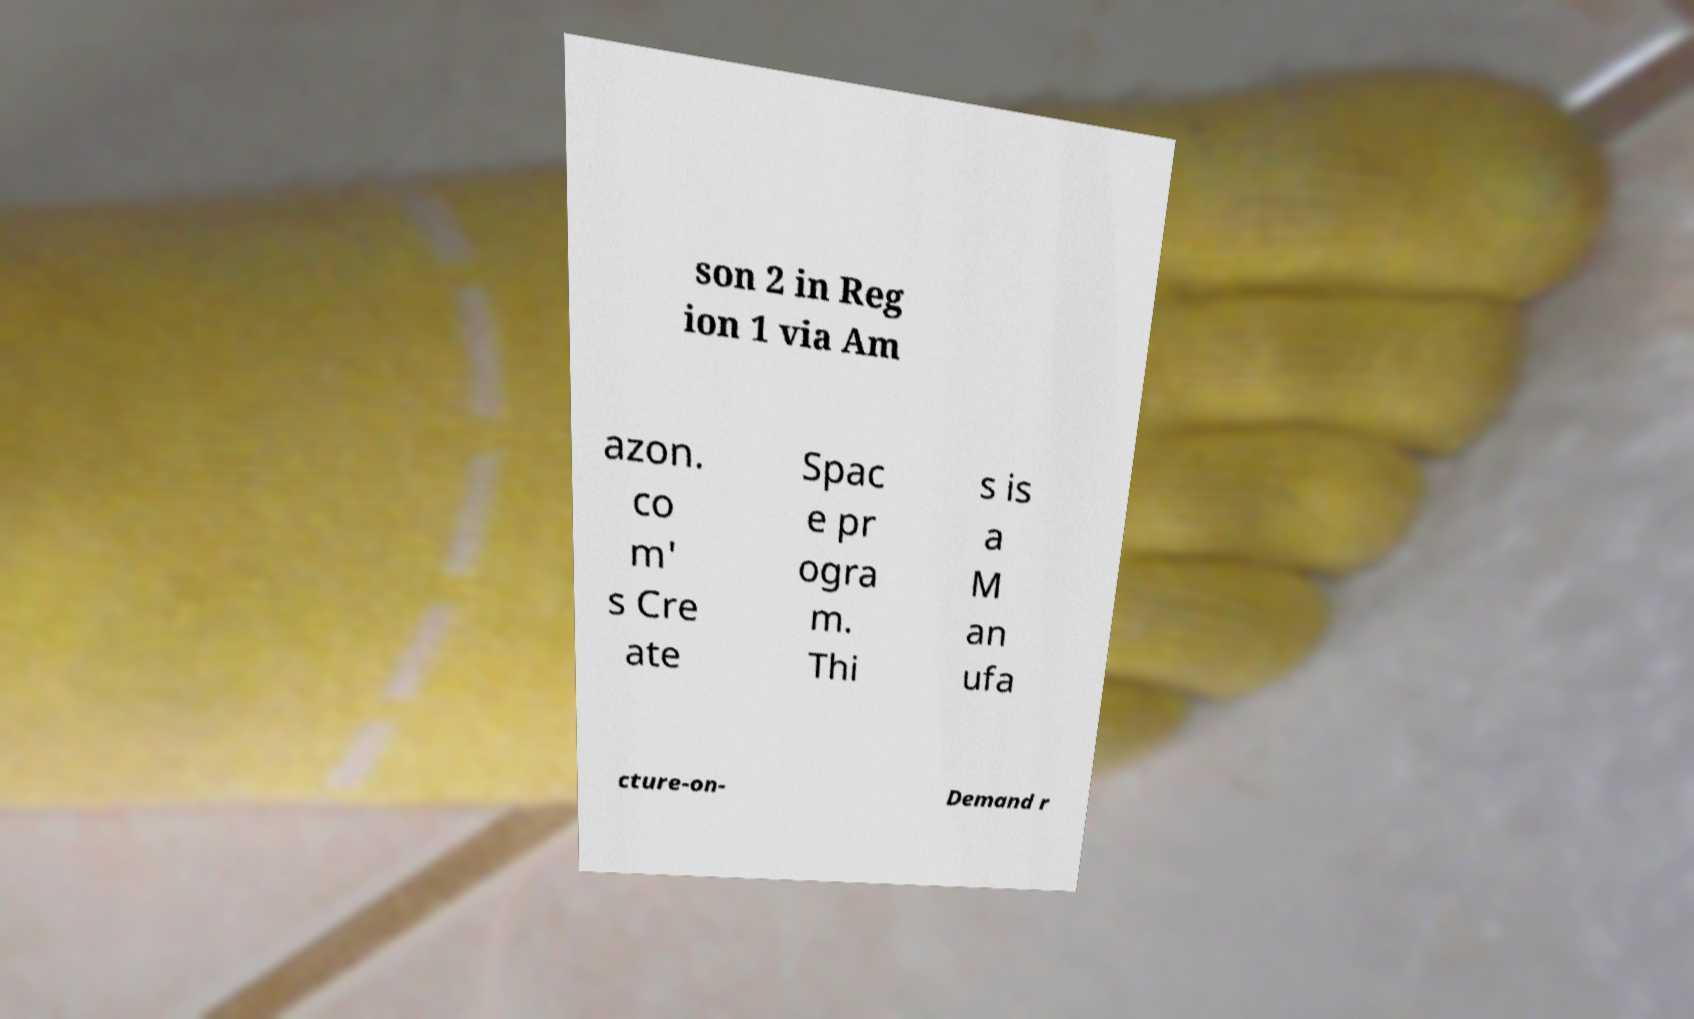Can you accurately transcribe the text from the provided image for me? son 2 in Reg ion 1 via Am azon. co m' s Cre ate Spac e pr ogra m. Thi s is a M an ufa cture-on- Demand r 